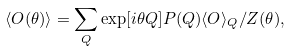Convert formula to latex. <formula><loc_0><loc_0><loc_500><loc_500>\langle O ( \theta ) \rangle = \sum _ { Q } \exp [ i \theta Q ] P ( Q ) \langle O \rangle _ { Q } / Z ( \theta ) ,</formula> 